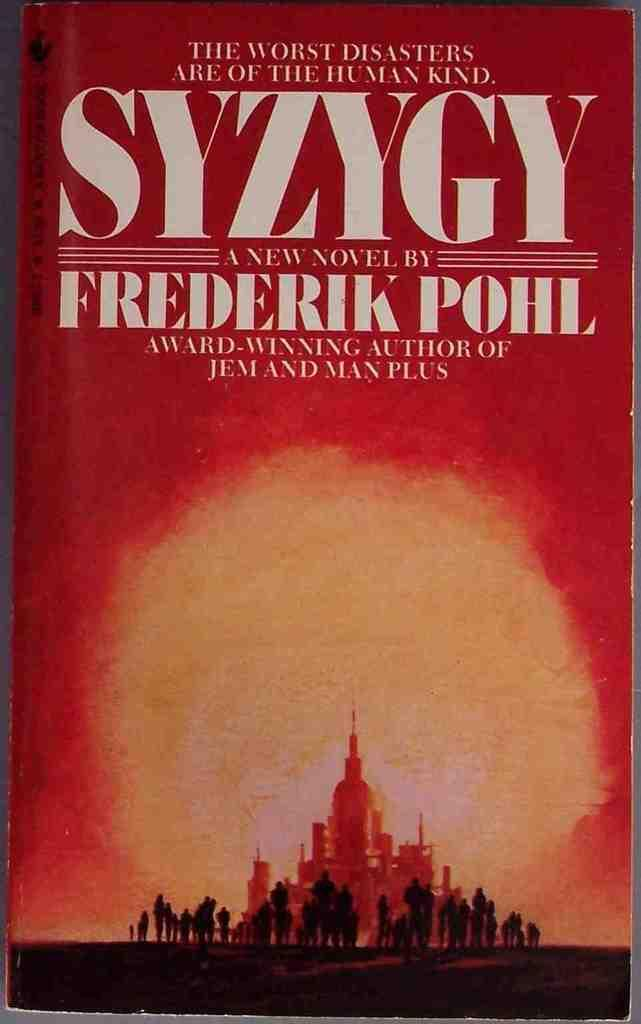Provide a one-sentence caption for the provided image. Book that is called SYZYGY which is a novel by Frederik Pohl. 